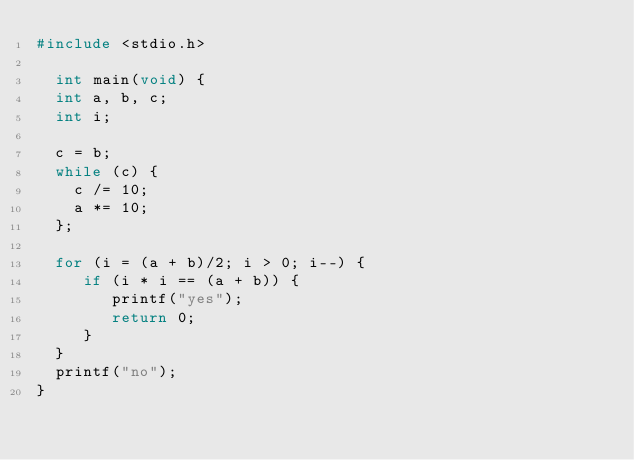Convert code to text. <code><loc_0><loc_0><loc_500><loc_500><_C_>#include <stdio.h>
 
  int main(void) {
  int a, b, c;
  int i;
 
  c = b;
  while (c) {
    c /= 10;
    a *= 10;
  };
  
  for (i = (a + b)/2; i > 0; i--) {
     if (i * i == (a + b)) {
        printf("yes");
        return 0;
     }
  } 
  printf("no");
}</code> 